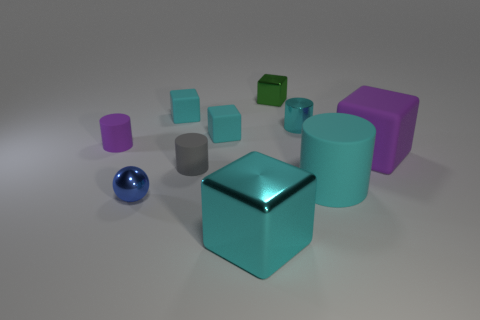Is there another shiny sphere that has the same color as the small shiny ball?
Your response must be concise. No. How many metal objects are either large green balls or gray cylinders?
Ensure brevity in your answer.  0. There is a purple object to the right of the blue sphere; how many tiny metal blocks are to the left of it?
Your answer should be compact. 1. What number of large objects have the same material as the small blue sphere?
Provide a short and direct response. 1. How many big things are cyan metallic objects or gray metal cylinders?
Keep it short and to the point. 1. There is a cyan thing that is behind the small purple thing and right of the large shiny cube; what is its shape?
Your response must be concise. Cylinder. Is the material of the tiny gray object the same as the big purple object?
Ensure brevity in your answer.  Yes. What is the color of the metal ball that is the same size as the metallic cylinder?
Offer a very short reply. Blue. There is a tiny cylinder that is behind the gray matte thing and to the left of the large metal block; what color is it?
Provide a short and direct response. Purple. What is the size of the other cylinder that is the same color as the big cylinder?
Make the answer very short. Small. 